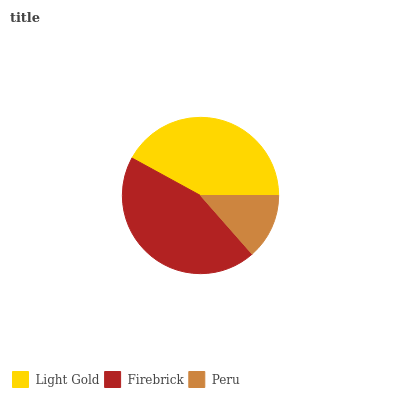Is Peru the minimum?
Answer yes or no. Yes. Is Firebrick the maximum?
Answer yes or no. Yes. Is Firebrick the minimum?
Answer yes or no. No. Is Peru the maximum?
Answer yes or no. No. Is Firebrick greater than Peru?
Answer yes or no. Yes. Is Peru less than Firebrick?
Answer yes or no. Yes. Is Peru greater than Firebrick?
Answer yes or no. No. Is Firebrick less than Peru?
Answer yes or no. No. Is Light Gold the high median?
Answer yes or no. Yes. Is Light Gold the low median?
Answer yes or no. Yes. Is Firebrick the high median?
Answer yes or no. No. Is Peru the low median?
Answer yes or no. No. 